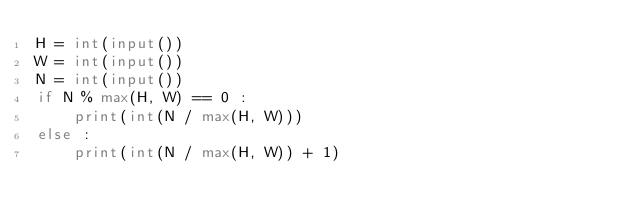<code> <loc_0><loc_0><loc_500><loc_500><_Python_>H = int(input())
W = int(input())
N = int(input())
if N % max(H, W) == 0 :
    print(int(N / max(H, W)))
else :
    print(int(N / max(H, W)) + 1)
</code> 